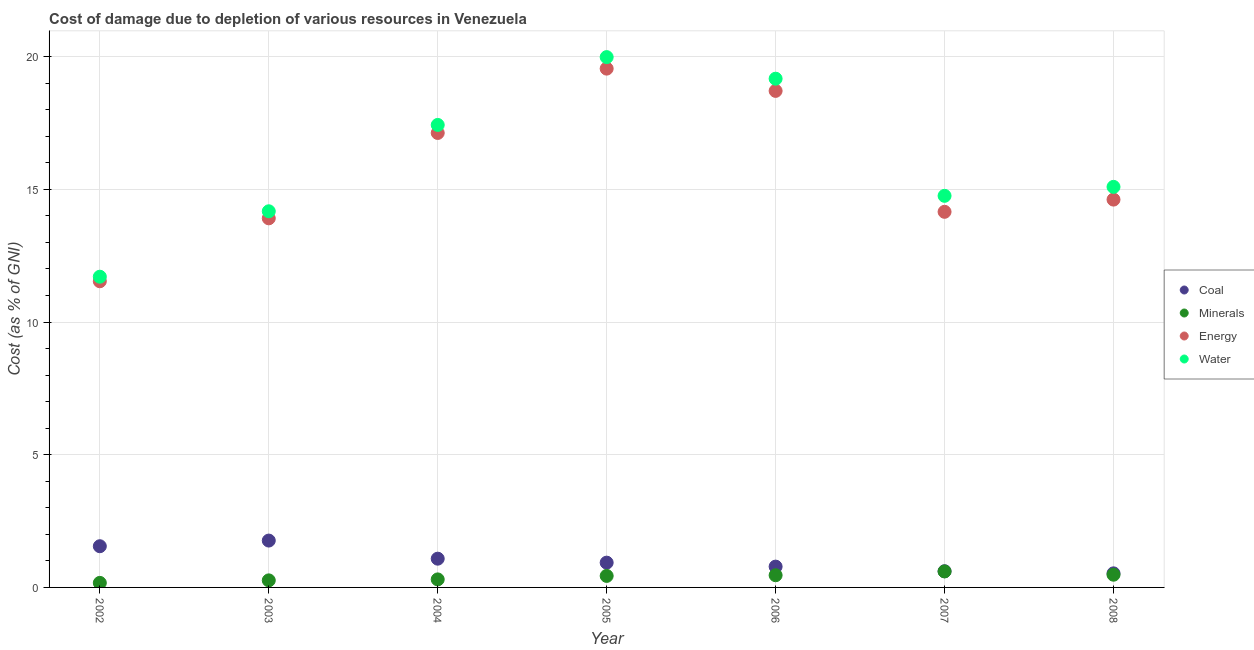Is the number of dotlines equal to the number of legend labels?
Offer a very short reply. Yes. What is the cost of damage due to depletion of energy in 2007?
Ensure brevity in your answer.  14.15. Across all years, what is the maximum cost of damage due to depletion of water?
Provide a succinct answer. 19.98. Across all years, what is the minimum cost of damage due to depletion of minerals?
Offer a very short reply. 0.17. In which year was the cost of damage due to depletion of water maximum?
Offer a terse response. 2005. What is the total cost of damage due to depletion of coal in the graph?
Provide a succinct answer. 7.26. What is the difference between the cost of damage due to depletion of minerals in 2006 and that in 2008?
Provide a succinct answer. -0.02. What is the difference between the cost of damage due to depletion of minerals in 2006 and the cost of damage due to depletion of coal in 2005?
Make the answer very short. -0.47. What is the average cost of damage due to depletion of water per year?
Provide a succinct answer. 16.05. In the year 2007, what is the difference between the cost of damage due to depletion of coal and cost of damage due to depletion of water?
Keep it short and to the point. -14.15. In how many years, is the cost of damage due to depletion of coal greater than 5 %?
Offer a terse response. 0. What is the ratio of the cost of damage due to depletion of energy in 2003 to that in 2005?
Make the answer very short. 0.71. What is the difference between the highest and the second highest cost of damage due to depletion of coal?
Your response must be concise. 0.21. What is the difference between the highest and the lowest cost of damage due to depletion of energy?
Offer a very short reply. 8.01. In how many years, is the cost of damage due to depletion of minerals greater than the average cost of damage due to depletion of minerals taken over all years?
Offer a very short reply. 4. Is it the case that in every year, the sum of the cost of damage due to depletion of coal and cost of damage due to depletion of minerals is greater than the cost of damage due to depletion of energy?
Make the answer very short. No. Is the cost of damage due to depletion of energy strictly greater than the cost of damage due to depletion of water over the years?
Provide a short and direct response. No. Is the cost of damage due to depletion of energy strictly less than the cost of damage due to depletion of water over the years?
Provide a succinct answer. Yes. How many dotlines are there?
Keep it short and to the point. 4. How many years are there in the graph?
Your response must be concise. 7. Where does the legend appear in the graph?
Offer a very short reply. Center right. How many legend labels are there?
Offer a very short reply. 4. How are the legend labels stacked?
Offer a very short reply. Vertical. What is the title of the graph?
Your response must be concise. Cost of damage due to depletion of various resources in Venezuela . What is the label or title of the X-axis?
Provide a short and direct response. Year. What is the label or title of the Y-axis?
Provide a succinct answer. Cost (as % of GNI). What is the Cost (as % of GNI) in Coal in 2002?
Provide a succinct answer. 1.55. What is the Cost (as % of GNI) in Minerals in 2002?
Provide a succinct answer. 0.17. What is the Cost (as % of GNI) in Energy in 2002?
Provide a succinct answer. 11.54. What is the Cost (as % of GNI) of Water in 2002?
Give a very brief answer. 11.71. What is the Cost (as % of GNI) in Coal in 2003?
Make the answer very short. 1.77. What is the Cost (as % of GNI) of Minerals in 2003?
Your answer should be very brief. 0.27. What is the Cost (as % of GNI) of Energy in 2003?
Ensure brevity in your answer.  13.91. What is the Cost (as % of GNI) of Water in 2003?
Offer a terse response. 14.17. What is the Cost (as % of GNI) in Coal in 2004?
Give a very brief answer. 1.08. What is the Cost (as % of GNI) in Minerals in 2004?
Provide a succinct answer. 0.3. What is the Cost (as % of GNI) in Energy in 2004?
Make the answer very short. 17.13. What is the Cost (as % of GNI) of Water in 2004?
Offer a very short reply. 17.43. What is the Cost (as % of GNI) in Coal in 2005?
Provide a succinct answer. 0.93. What is the Cost (as % of GNI) of Minerals in 2005?
Provide a short and direct response. 0.43. What is the Cost (as % of GNI) in Energy in 2005?
Ensure brevity in your answer.  19.55. What is the Cost (as % of GNI) of Water in 2005?
Offer a terse response. 19.98. What is the Cost (as % of GNI) in Coal in 2006?
Keep it short and to the point. 0.78. What is the Cost (as % of GNI) in Minerals in 2006?
Ensure brevity in your answer.  0.46. What is the Cost (as % of GNI) in Energy in 2006?
Offer a very short reply. 18.71. What is the Cost (as % of GNI) in Water in 2006?
Keep it short and to the point. 19.17. What is the Cost (as % of GNI) in Coal in 2007?
Give a very brief answer. 0.61. What is the Cost (as % of GNI) of Minerals in 2007?
Offer a very short reply. 0.6. What is the Cost (as % of GNI) in Energy in 2007?
Provide a short and direct response. 14.15. What is the Cost (as % of GNI) in Water in 2007?
Your answer should be very brief. 14.76. What is the Cost (as % of GNI) of Coal in 2008?
Provide a succinct answer. 0.53. What is the Cost (as % of GNI) of Minerals in 2008?
Offer a very short reply. 0.48. What is the Cost (as % of GNI) of Energy in 2008?
Provide a short and direct response. 14.62. What is the Cost (as % of GNI) in Water in 2008?
Make the answer very short. 15.09. Across all years, what is the maximum Cost (as % of GNI) of Coal?
Keep it short and to the point. 1.77. Across all years, what is the maximum Cost (as % of GNI) of Minerals?
Offer a very short reply. 0.6. Across all years, what is the maximum Cost (as % of GNI) of Energy?
Provide a short and direct response. 19.55. Across all years, what is the maximum Cost (as % of GNI) in Water?
Make the answer very short. 19.98. Across all years, what is the minimum Cost (as % of GNI) in Coal?
Your answer should be compact. 0.53. Across all years, what is the minimum Cost (as % of GNI) of Minerals?
Make the answer very short. 0.17. Across all years, what is the minimum Cost (as % of GNI) of Energy?
Give a very brief answer. 11.54. Across all years, what is the minimum Cost (as % of GNI) of Water?
Provide a succinct answer. 11.71. What is the total Cost (as % of GNI) of Coal in the graph?
Keep it short and to the point. 7.26. What is the total Cost (as % of GNI) in Minerals in the graph?
Offer a very short reply. 2.71. What is the total Cost (as % of GNI) in Energy in the graph?
Give a very brief answer. 109.61. What is the total Cost (as % of GNI) of Water in the graph?
Offer a very short reply. 112.32. What is the difference between the Cost (as % of GNI) in Coal in 2002 and that in 2003?
Offer a very short reply. -0.21. What is the difference between the Cost (as % of GNI) of Minerals in 2002 and that in 2003?
Make the answer very short. -0.1. What is the difference between the Cost (as % of GNI) in Energy in 2002 and that in 2003?
Your response must be concise. -2.37. What is the difference between the Cost (as % of GNI) of Water in 2002 and that in 2003?
Offer a very short reply. -2.47. What is the difference between the Cost (as % of GNI) of Coal in 2002 and that in 2004?
Your answer should be very brief. 0.47. What is the difference between the Cost (as % of GNI) of Minerals in 2002 and that in 2004?
Your answer should be very brief. -0.13. What is the difference between the Cost (as % of GNI) of Energy in 2002 and that in 2004?
Keep it short and to the point. -5.59. What is the difference between the Cost (as % of GNI) in Water in 2002 and that in 2004?
Ensure brevity in your answer.  -5.72. What is the difference between the Cost (as % of GNI) in Coal in 2002 and that in 2005?
Offer a terse response. 0.62. What is the difference between the Cost (as % of GNI) of Minerals in 2002 and that in 2005?
Make the answer very short. -0.26. What is the difference between the Cost (as % of GNI) in Energy in 2002 and that in 2005?
Keep it short and to the point. -8.01. What is the difference between the Cost (as % of GNI) in Water in 2002 and that in 2005?
Offer a very short reply. -8.28. What is the difference between the Cost (as % of GNI) of Coal in 2002 and that in 2006?
Your answer should be very brief. 0.77. What is the difference between the Cost (as % of GNI) of Minerals in 2002 and that in 2006?
Provide a succinct answer. -0.29. What is the difference between the Cost (as % of GNI) in Energy in 2002 and that in 2006?
Ensure brevity in your answer.  -7.17. What is the difference between the Cost (as % of GNI) of Water in 2002 and that in 2006?
Give a very brief answer. -7.46. What is the difference between the Cost (as % of GNI) of Coal in 2002 and that in 2007?
Ensure brevity in your answer.  0.94. What is the difference between the Cost (as % of GNI) of Minerals in 2002 and that in 2007?
Your answer should be compact. -0.43. What is the difference between the Cost (as % of GNI) in Energy in 2002 and that in 2007?
Your answer should be very brief. -2.62. What is the difference between the Cost (as % of GNI) of Water in 2002 and that in 2007?
Ensure brevity in your answer.  -3.05. What is the difference between the Cost (as % of GNI) of Coal in 2002 and that in 2008?
Your answer should be very brief. 1.02. What is the difference between the Cost (as % of GNI) in Minerals in 2002 and that in 2008?
Ensure brevity in your answer.  -0.31. What is the difference between the Cost (as % of GNI) of Energy in 2002 and that in 2008?
Offer a very short reply. -3.08. What is the difference between the Cost (as % of GNI) in Water in 2002 and that in 2008?
Provide a succinct answer. -3.39. What is the difference between the Cost (as % of GNI) in Coal in 2003 and that in 2004?
Your answer should be compact. 0.68. What is the difference between the Cost (as % of GNI) in Minerals in 2003 and that in 2004?
Your answer should be compact. -0.04. What is the difference between the Cost (as % of GNI) of Energy in 2003 and that in 2004?
Offer a terse response. -3.22. What is the difference between the Cost (as % of GNI) of Water in 2003 and that in 2004?
Ensure brevity in your answer.  -3.25. What is the difference between the Cost (as % of GNI) in Coal in 2003 and that in 2005?
Provide a short and direct response. 0.83. What is the difference between the Cost (as % of GNI) of Minerals in 2003 and that in 2005?
Your answer should be very brief. -0.17. What is the difference between the Cost (as % of GNI) in Energy in 2003 and that in 2005?
Keep it short and to the point. -5.64. What is the difference between the Cost (as % of GNI) in Water in 2003 and that in 2005?
Provide a succinct answer. -5.81. What is the difference between the Cost (as % of GNI) of Coal in 2003 and that in 2006?
Give a very brief answer. 0.98. What is the difference between the Cost (as % of GNI) of Minerals in 2003 and that in 2006?
Offer a terse response. -0.19. What is the difference between the Cost (as % of GNI) of Energy in 2003 and that in 2006?
Ensure brevity in your answer.  -4.8. What is the difference between the Cost (as % of GNI) of Water in 2003 and that in 2006?
Make the answer very short. -5. What is the difference between the Cost (as % of GNI) of Coal in 2003 and that in 2007?
Provide a short and direct response. 1.16. What is the difference between the Cost (as % of GNI) of Minerals in 2003 and that in 2007?
Provide a short and direct response. -0.34. What is the difference between the Cost (as % of GNI) in Energy in 2003 and that in 2007?
Give a very brief answer. -0.25. What is the difference between the Cost (as % of GNI) of Water in 2003 and that in 2007?
Make the answer very short. -0.58. What is the difference between the Cost (as % of GNI) of Coal in 2003 and that in 2008?
Your response must be concise. 1.24. What is the difference between the Cost (as % of GNI) in Minerals in 2003 and that in 2008?
Offer a very short reply. -0.21. What is the difference between the Cost (as % of GNI) of Energy in 2003 and that in 2008?
Your answer should be compact. -0.71. What is the difference between the Cost (as % of GNI) in Water in 2003 and that in 2008?
Provide a short and direct response. -0.92. What is the difference between the Cost (as % of GNI) in Coal in 2004 and that in 2005?
Keep it short and to the point. 0.15. What is the difference between the Cost (as % of GNI) of Minerals in 2004 and that in 2005?
Give a very brief answer. -0.13. What is the difference between the Cost (as % of GNI) in Energy in 2004 and that in 2005?
Provide a short and direct response. -2.42. What is the difference between the Cost (as % of GNI) of Water in 2004 and that in 2005?
Your answer should be very brief. -2.56. What is the difference between the Cost (as % of GNI) in Coal in 2004 and that in 2006?
Provide a succinct answer. 0.3. What is the difference between the Cost (as % of GNI) in Minerals in 2004 and that in 2006?
Provide a succinct answer. -0.16. What is the difference between the Cost (as % of GNI) of Energy in 2004 and that in 2006?
Give a very brief answer. -1.59. What is the difference between the Cost (as % of GNI) of Water in 2004 and that in 2006?
Your response must be concise. -1.74. What is the difference between the Cost (as % of GNI) in Coal in 2004 and that in 2007?
Ensure brevity in your answer.  0.47. What is the difference between the Cost (as % of GNI) in Minerals in 2004 and that in 2007?
Your response must be concise. -0.3. What is the difference between the Cost (as % of GNI) of Energy in 2004 and that in 2007?
Your response must be concise. 2.97. What is the difference between the Cost (as % of GNI) of Water in 2004 and that in 2007?
Make the answer very short. 2.67. What is the difference between the Cost (as % of GNI) of Coal in 2004 and that in 2008?
Your answer should be compact. 0.55. What is the difference between the Cost (as % of GNI) in Minerals in 2004 and that in 2008?
Offer a terse response. -0.18. What is the difference between the Cost (as % of GNI) of Energy in 2004 and that in 2008?
Offer a very short reply. 2.51. What is the difference between the Cost (as % of GNI) of Water in 2004 and that in 2008?
Keep it short and to the point. 2.33. What is the difference between the Cost (as % of GNI) in Coal in 2005 and that in 2006?
Offer a terse response. 0.15. What is the difference between the Cost (as % of GNI) of Minerals in 2005 and that in 2006?
Give a very brief answer. -0.03. What is the difference between the Cost (as % of GNI) in Energy in 2005 and that in 2006?
Provide a short and direct response. 0.84. What is the difference between the Cost (as % of GNI) of Water in 2005 and that in 2006?
Offer a terse response. 0.81. What is the difference between the Cost (as % of GNI) of Coal in 2005 and that in 2007?
Provide a succinct answer. 0.32. What is the difference between the Cost (as % of GNI) of Minerals in 2005 and that in 2007?
Your answer should be compact. -0.17. What is the difference between the Cost (as % of GNI) of Energy in 2005 and that in 2007?
Your answer should be compact. 5.4. What is the difference between the Cost (as % of GNI) of Water in 2005 and that in 2007?
Keep it short and to the point. 5.23. What is the difference between the Cost (as % of GNI) in Coal in 2005 and that in 2008?
Your answer should be compact. 0.4. What is the difference between the Cost (as % of GNI) of Minerals in 2005 and that in 2008?
Provide a succinct answer. -0.05. What is the difference between the Cost (as % of GNI) of Energy in 2005 and that in 2008?
Give a very brief answer. 4.94. What is the difference between the Cost (as % of GNI) in Water in 2005 and that in 2008?
Ensure brevity in your answer.  4.89. What is the difference between the Cost (as % of GNI) in Coal in 2006 and that in 2007?
Offer a very short reply. 0.17. What is the difference between the Cost (as % of GNI) of Minerals in 2006 and that in 2007?
Keep it short and to the point. -0.14. What is the difference between the Cost (as % of GNI) of Energy in 2006 and that in 2007?
Keep it short and to the point. 4.56. What is the difference between the Cost (as % of GNI) of Water in 2006 and that in 2007?
Ensure brevity in your answer.  4.41. What is the difference between the Cost (as % of GNI) of Coal in 2006 and that in 2008?
Provide a succinct answer. 0.25. What is the difference between the Cost (as % of GNI) in Minerals in 2006 and that in 2008?
Your answer should be very brief. -0.02. What is the difference between the Cost (as % of GNI) in Energy in 2006 and that in 2008?
Give a very brief answer. 4.1. What is the difference between the Cost (as % of GNI) in Water in 2006 and that in 2008?
Provide a succinct answer. 4.08. What is the difference between the Cost (as % of GNI) in Coal in 2007 and that in 2008?
Offer a terse response. 0.08. What is the difference between the Cost (as % of GNI) in Minerals in 2007 and that in 2008?
Give a very brief answer. 0.12. What is the difference between the Cost (as % of GNI) of Energy in 2007 and that in 2008?
Your response must be concise. -0.46. What is the difference between the Cost (as % of GNI) in Water in 2007 and that in 2008?
Offer a terse response. -0.34. What is the difference between the Cost (as % of GNI) of Coal in 2002 and the Cost (as % of GNI) of Minerals in 2003?
Provide a succinct answer. 1.29. What is the difference between the Cost (as % of GNI) of Coal in 2002 and the Cost (as % of GNI) of Energy in 2003?
Keep it short and to the point. -12.36. What is the difference between the Cost (as % of GNI) in Coal in 2002 and the Cost (as % of GNI) in Water in 2003?
Your response must be concise. -12.62. What is the difference between the Cost (as % of GNI) of Minerals in 2002 and the Cost (as % of GNI) of Energy in 2003?
Offer a terse response. -13.74. What is the difference between the Cost (as % of GNI) of Minerals in 2002 and the Cost (as % of GNI) of Water in 2003?
Provide a short and direct response. -14. What is the difference between the Cost (as % of GNI) of Energy in 2002 and the Cost (as % of GNI) of Water in 2003?
Keep it short and to the point. -2.64. What is the difference between the Cost (as % of GNI) in Coal in 2002 and the Cost (as % of GNI) in Minerals in 2004?
Offer a very short reply. 1.25. What is the difference between the Cost (as % of GNI) in Coal in 2002 and the Cost (as % of GNI) in Energy in 2004?
Keep it short and to the point. -15.57. What is the difference between the Cost (as % of GNI) of Coal in 2002 and the Cost (as % of GNI) of Water in 2004?
Offer a very short reply. -15.88. What is the difference between the Cost (as % of GNI) of Minerals in 2002 and the Cost (as % of GNI) of Energy in 2004?
Offer a terse response. -16.96. What is the difference between the Cost (as % of GNI) in Minerals in 2002 and the Cost (as % of GNI) in Water in 2004?
Ensure brevity in your answer.  -17.26. What is the difference between the Cost (as % of GNI) in Energy in 2002 and the Cost (as % of GNI) in Water in 2004?
Provide a short and direct response. -5.89. What is the difference between the Cost (as % of GNI) of Coal in 2002 and the Cost (as % of GNI) of Minerals in 2005?
Ensure brevity in your answer.  1.12. What is the difference between the Cost (as % of GNI) in Coal in 2002 and the Cost (as % of GNI) in Energy in 2005?
Your answer should be very brief. -18. What is the difference between the Cost (as % of GNI) of Coal in 2002 and the Cost (as % of GNI) of Water in 2005?
Give a very brief answer. -18.43. What is the difference between the Cost (as % of GNI) in Minerals in 2002 and the Cost (as % of GNI) in Energy in 2005?
Keep it short and to the point. -19.38. What is the difference between the Cost (as % of GNI) of Minerals in 2002 and the Cost (as % of GNI) of Water in 2005?
Make the answer very short. -19.81. What is the difference between the Cost (as % of GNI) of Energy in 2002 and the Cost (as % of GNI) of Water in 2005?
Keep it short and to the point. -8.45. What is the difference between the Cost (as % of GNI) of Coal in 2002 and the Cost (as % of GNI) of Minerals in 2006?
Make the answer very short. 1.09. What is the difference between the Cost (as % of GNI) in Coal in 2002 and the Cost (as % of GNI) in Energy in 2006?
Provide a succinct answer. -17.16. What is the difference between the Cost (as % of GNI) in Coal in 2002 and the Cost (as % of GNI) in Water in 2006?
Your response must be concise. -17.62. What is the difference between the Cost (as % of GNI) in Minerals in 2002 and the Cost (as % of GNI) in Energy in 2006?
Provide a succinct answer. -18.54. What is the difference between the Cost (as % of GNI) in Minerals in 2002 and the Cost (as % of GNI) in Water in 2006?
Ensure brevity in your answer.  -19. What is the difference between the Cost (as % of GNI) in Energy in 2002 and the Cost (as % of GNI) in Water in 2006?
Give a very brief answer. -7.63. What is the difference between the Cost (as % of GNI) in Coal in 2002 and the Cost (as % of GNI) in Minerals in 2007?
Your answer should be compact. 0.95. What is the difference between the Cost (as % of GNI) in Coal in 2002 and the Cost (as % of GNI) in Energy in 2007?
Your answer should be compact. -12.6. What is the difference between the Cost (as % of GNI) of Coal in 2002 and the Cost (as % of GNI) of Water in 2007?
Keep it short and to the point. -13.2. What is the difference between the Cost (as % of GNI) of Minerals in 2002 and the Cost (as % of GNI) of Energy in 2007?
Ensure brevity in your answer.  -13.98. What is the difference between the Cost (as % of GNI) in Minerals in 2002 and the Cost (as % of GNI) in Water in 2007?
Provide a short and direct response. -14.59. What is the difference between the Cost (as % of GNI) of Energy in 2002 and the Cost (as % of GNI) of Water in 2007?
Provide a short and direct response. -3.22. What is the difference between the Cost (as % of GNI) in Coal in 2002 and the Cost (as % of GNI) in Minerals in 2008?
Provide a succinct answer. 1.07. What is the difference between the Cost (as % of GNI) of Coal in 2002 and the Cost (as % of GNI) of Energy in 2008?
Your response must be concise. -13.06. What is the difference between the Cost (as % of GNI) in Coal in 2002 and the Cost (as % of GNI) in Water in 2008?
Offer a very short reply. -13.54. What is the difference between the Cost (as % of GNI) in Minerals in 2002 and the Cost (as % of GNI) in Energy in 2008?
Make the answer very short. -14.44. What is the difference between the Cost (as % of GNI) of Minerals in 2002 and the Cost (as % of GNI) of Water in 2008?
Your response must be concise. -14.92. What is the difference between the Cost (as % of GNI) in Energy in 2002 and the Cost (as % of GNI) in Water in 2008?
Your response must be concise. -3.56. What is the difference between the Cost (as % of GNI) in Coal in 2003 and the Cost (as % of GNI) in Minerals in 2004?
Your response must be concise. 1.46. What is the difference between the Cost (as % of GNI) of Coal in 2003 and the Cost (as % of GNI) of Energy in 2004?
Provide a short and direct response. -15.36. What is the difference between the Cost (as % of GNI) in Coal in 2003 and the Cost (as % of GNI) in Water in 2004?
Your answer should be very brief. -15.66. What is the difference between the Cost (as % of GNI) in Minerals in 2003 and the Cost (as % of GNI) in Energy in 2004?
Give a very brief answer. -16.86. What is the difference between the Cost (as % of GNI) in Minerals in 2003 and the Cost (as % of GNI) in Water in 2004?
Offer a very short reply. -17.16. What is the difference between the Cost (as % of GNI) in Energy in 2003 and the Cost (as % of GNI) in Water in 2004?
Ensure brevity in your answer.  -3.52. What is the difference between the Cost (as % of GNI) in Coal in 2003 and the Cost (as % of GNI) in Minerals in 2005?
Your answer should be very brief. 1.33. What is the difference between the Cost (as % of GNI) in Coal in 2003 and the Cost (as % of GNI) in Energy in 2005?
Offer a very short reply. -17.79. What is the difference between the Cost (as % of GNI) of Coal in 2003 and the Cost (as % of GNI) of Water in 2005?
Your response must be concise. -18.22. What is the difference between the Cost (as % of GNI) in Minerals in 2003 and the Cost (as % of GNI) in Energy in 2005?
Your response must be concise. -19.28. What is the difference between the Cost (as % of GNI) in Minerals in 2003 and the Cost (as % of GNI) in Water in 2005?
Your response must be concise. -19.72. What is the difference between the Cost (as % of GNI) of Energy in 2003 and the Cost (as % of GNI) of Water in 2005?
Give a very brief answer. -6.08. What is the difference between the Cost (as % of GNI) of Coal in 2003 and the Cost (as % of GNI) of Minerals in 2006?
Make the answer very short. 1.31. What is the difference between the Cost (as % of GNI) in Coal in 2003 and the Cost (as % of GNI) in Energy in 2006?
Provide a short and direct response. -16.95. What is the difference between the Cost (as % of GNI) of Coal in 2003 and the Cost (as % of GNI) of Water in 2006?
Offer a terse response. -17.41. What is the difference between the Cost (as % of GNI) in Minerals in 2003 and the Cost (as % of GNI) in Energy in 2006?
Your answer should be compact. -18.45. What is the difference between the Cost (as % of GNI) of Minerals in 2003 and the Cost (as % of GNI) of Water in 2006?
Your answer should be compact. -18.91. What is the difference between the Cost (as % of GNI) of Energy in 2003 and the Cost (as % of GNI) of Water in 2006?
Make the answer very short. -5.26. What is the difference between the Cost (as % of GNI) of Coal in 2003 and the Cost (as % of GNI) of Minerals in 2007?
Your response must be concise. 1.16. What is the difference between the Cost (as % of GNI) in Coal in 2003 and the Cost (as % of GNI) in Energy in 2007?
Keep it short and to the point. -12.39. What is the difference between the Cost (as % of GNI) in Coal in 2003 and the Cost (as % of GNI) in Water in 2007?
Keep it short and to the point. -12.99. What is the difference between the Cost (as % of GNI) of Minerals in 2003 and the Cost (as % of GNI) of Energy in 2007?
Ensure brevity in your answer.  -13.89. What is the difference between the Cost (as % of GNI) of Minerals in 2003 and the Cost (as % of GNI) of Water in 2007?
Offer a terse response. -14.49. What is the difference between the Cost (as % of GNI) of Energy in 2003 and the Cost (as % of GNI) of Water in 2007?
Ensure brevity in your answer.  -0.85. What is the difference between the Cost (as % of GNI) in Coal in 2003 and the Cost (as % of GNI) in Minerals in 2008?
Your answer should be very brief. 1.29. What is the difference between the Cost (as % of GNI) in Coal in 2003 and the Cost (as % of GNI) in Energy in 2008?
Make the answer very short. -12.85. What is the difference between the Cost (as % of GNI) in Coal in 2003 and the Cost (as % of GNI) in Water in 2008?
Provide a succinct answer. -13.33. What is the difference between the Cost (as % of GNI) of Minerals in 2003 and the Cost (as % of GNI) of Energy in 2008?
Your answer should be very brief. -14.35. What is the difference between the Cost (as % of GNI) of Minerals in 2003 and the Cost (as % of GNI) of Water in 2008?
Provide a short and direct response. -14.83. What is the difference between the Cost (as % of GNI) of Energy in 2003 and the Cost (as % of GNI) of Water in 2008?
Your answer should be compact. -1.19. What is the difference between the Cost (as % of GNI) in Coal in 2004 and the Cost (as % of GNI) in Minerals in 2005?
Offer a very short reply. 0.65. What is the difference between the Cost (as % of GNI) of Coal in 2004 and the Cost (as % of GNI) of Energy in 2005?
Offer a terse response. -18.47. What is the difference between the Cost (as % of GNI) in Coal in 2004 and the Cost (as % of GNI) in Water in 2005?
Offer a terse response. -18.9. What is the difference between the Cost (as % of GNI) in Minerals in 2004 and the Cost (as % of GNI) in Energy in 2005?
Offer a terse response. -19.25. What is the difference between the Cost (as % of GNI) in Minerals in 2004 and the Cost (as % of GNI) in Water in 2005?
Provide a succinct answer. -19.68. What is the difference between the Cost (as % of GNI) in Energy in 2004 and the Cost (as % of GNI) in Water in 2005?
Your answer should be compact. -2.86. What is the difference between the Cost (as % of GNI) in Coal in 2004 and the Cost (as % of GNI) in Minerals in 2006?
Keep it short and to the point. 0.62. What is the difference between the Cost (as % of GNI) in Coal in 2004 and the Cost (as % of GNI) in Energy in 2006?
Your answer should be compact. -17.63. What is the difference between the Cost (as % of GNI) of Coal in 2004 and the Cost (as % of GNI) of Water in 2006?
Your answer should be compact. -18.09. What is the difference between the Cost (as % of GNI) in Minerals in 2004 and the Cost (as % of GNI) in Energy in 2006?
Your answer should be compact. -18.41. What is the difference between the Cost (as % of GNI) of Minerals in 2004 and the Cost (as % of GNI) of Water in 2006?
Provide a succinct answer. -18.87. What is the difference between the Cost (as % of GNI) in Energy in 2004 and the Cost (as % of GNI) in Water in 2006?
Provide a succinct answer. -2.04. What is the difference between the Cost (as % of GNI) of Coal in 2004 and the Cost (as % of GNI) of Minerals in 2007?
Make the answer very short. 0.48. What is the difference between the Cost (as % of GNI) of Coal in 2004 and the Cost (as % of GNI) of Energy in 2007?
Make the answer very short. -13.07. What is the difference between the Cost (as % of GNI) of Coal in 2004 and the Cost (as % of GNI) of Water in 2007?
Your answer should be very brief. -13.67. What is the difference between the Cost (as % of GNI) in Minerals in 2004 and the Cost (as % of GNI) in Energy in 2007?
Keep it short and to the point. -13.85. What is the difference between the Cost (as % of GNI) in Minerals in 2004 and the Cost (as % of GNI) in Water in 2007?
Offer a terse response. -14.45. What is the difference between the Cost (as % of GNI) in Energy in 2004 and the Cost (as % of GNI) in Water in 2007?
Your answer should be compact. 2.37. What is the difference between the Cost (as % of GNI) in Coal in 2004 and the Cost (as % of GNI) in Minerals in 2008?
Give a very brief answer. 0.6. What is the difference between the Cost (as % of GNI) of Coal in 2004 and the Cost (as % of GNI) of Energy in 2008?
Give a very brief answer. -13.53. What is the difference between the Cost (as % of GNI) in Coal in 2004 and the Cost (as % of GNI) in Water in 2008?
Your answer should be very brief. -14.01. What is the difference between the Cost (as % of GNI) in Minerals in 2004 and the Cost (as % of GNI) in Energy in 2008?
Offer a very short reply. -14.31. What is the difference between the Cost (as % of GNI) of Minerals in 2004 and the Cost (as % of GNI) of Water in 2008?
Give a very brief answer. -14.79. What is the difference between the Cost (as % of GNI) in Energy in 2004 and the Cost (as % of GNI) in Water in 2008?
Make the answer very short. 2.03. What is the difference between the Cost (as % of GNI) in Coal in 2005 and the Cost (as % of GNI) in Minerals in 2006?
Provide a short and direct response. 0.47. What is the difference between the Cost (as % of GNI) in Coal in 2005 and the Cost (as % of GNI) in Energy in 2006?
Your answer should be very brief. -17.78. What is the difference between the Cost (as % of GNI) in Coal in 2005 and the Cost (as % of GNI) in Water in 2006?
Your response must be concise. -18.24. What is the difference between the Cost (as % of GNI) of Minerals in 2005 and the Cost (as % of GNI) of Energy in 2006?
Your response must be concise. -18.28. What is the difference between the Cost (as % of GNI) in Minerals in 2005 and the Cost (as % of GNI) in Water in 2006?
Ensure brevity in your answer.  -18.74. What is the difference between the Cost (as % of GNI) in Energy in 2005 and the Cost (as % of GNI) in Water in 2006?
Your answer should be very brief. 0.38. What is the difference between the Cost (as % of GNI) in Coal in 2005 and the Cost (as % of GNI) in Minerals in 2007?
Provide a short and direct response. 0.33. What is the difference between the Cost (as % of GNI) in Coal in 2005 and the Cost (as % of GNI) in Energy in 2007?
Provide a succinct answer. -13.22. What is the difference between the Cost (as % of GNI) in Coal in 2005 and the Cost (as % of GNI) in Water in 2007?
Offer a very short reply. -13.82. What is the difference between the Cost (as % of GNI) in Minerals in 2005 and the Cost (as % of GNI) in Energy in 2007?
Give a very brief answer. -13.72. What is the difference between the Cost (as % of GNI) of Minerals in 2005 and the Cost (as % of GNI) of Water in 2007?
Offer a terse response. -14.32. What is the difference between the Cost (as % of GNI) in Energy in 2005 and the Cost (as % of GNI) in Water in 2007?
Keep it short and to the point. 4.79. What is the difference between the Cost (as % of GNI) of Coal in 2005 and the Cost (as % of GNI) of Minerals in 2008?
Your answer should be compact. 0.45. What is the difference between the Cost (as % of GNI) of Coal in 2005 and the Cost (as % of GNI) of Energy in 2008?
Provide a short and direct response. -13.68. What is the difference between the Cost (as % of GNI) in Coal in 2005 and the Cost (as % of GNI) in Water in 2008?
Give a very brief answer. -14.16. What is the difference between the Cost (as % of GNI) in Minerals in 2005 and the Cost (as % of GNI) in Energy in 2008?
Offer a terse response. -14.18. What is the difference between the Cost (as % of GNI) in Minerals in 2005 and the Cost (as % of GNI) in Water in 2008?
Provide a short and direct response. -14.66. What is the difference between the Cost (as % of GNI) of Energy in 2005 and the Cost (as % of GNI) of Water in 2008?
Ensure brevity in your answer.  4.46. What is the difference between the Cost (as % of GNI) of Coal in 2006 and the Cost (as % of GNI) of Minerals in 2007?
Give a very brief answer. 0.18. What is the difference between the Cost (as % of GNI) of Coal in 2006 and the Cost (as % of GNI) of Energy in 2007?
Your answer should be compact. -13.37. What is the difference between the Cost (as % of GNI) in Coal in 2006 and the Cost (as % of GNI) in Water in 2007?
Give a very brief answer. -13.97. What is the difference between the Cost (as % of GNI) in Minerals in 2006 and the Cost (as % of GNI) in Energy in 2007?
Offer a terse response. -13.7. What is the difference between the Cost (as % of GNI) of Minerals in 2006 and the Cost (as % of GNI) of Water in 2007?
Offer a terse response. -14.3. What is the difference between the Cost (as % of GNI) in Energy in 2006 and the Cost (as % of GNI) in Water in 2007?
Offer a terse response. 3.95. What is the difference between the Cost (as % of GNI) in Coal in 2006 and the Cost (as % of GNI) in Minerals in 2008?
Your answer should be very brief. 0.31. What is the difference between the Cost (as % of GNI) in Coal in 2006 and the Cost (as % of GNI) in Energy in 2008?
Your answer should be very brief. -13.83. What is the difference between the Cost (as % of GNI) of Coal in 2006 and the Cost (as % of GNI) of Water in 2008?
Provide a succinct answer. -14.31. What is the difference between the Cost (as % of GNI) of Minerals in 2006 and the Cost (as % of GNI) of Energy in 2008?
Provide a succinct answer. -14.16. What is the difference between the Cost (as % of GNI) in Minerals in 2006 and the Cost (as % of GNI) in Water in 2008?
Offer a very short reply. -14.63. What is the difference between the Cost (as % of GNI) in Energy in 2006 and the Cost (as % of GNI) in Water in 2008?
Your answer should be very brief. 3.62. What is the difference between the Cost (as % of GNI) in Coal in 2007 and the Cost (as % of GNI) in Minerals in 2008?
Give a very brief answer. 0.13. What is the difference between the Cost (as % of GNI) of Coal in 2007 and the Cost (as % of GNI) of Energy in 2008?
Keep it short and to the point. -14.01. What is the difference between the Cost (as % of GNI) of Coal in 2007 and the Cost (as % of GNI) of Water in 2008?
Your response must be concise. -14.48. What is the difference between the Cost (as % of GNI) of Minerals in 2007 and the Cost (as % of GNI) of Energy in 2008?
Your answer should be very brief. -14.01. What is the difference between the Cost (as % of GNI) of Minerals in 2007 and the Cost (as % of GNI) of Water in 2008?
Ensure brevity in your answer.  -14.49. What is the difference between the Cost (as % of GNI) in Energy in 2007 and the Cost (as % of GNI) in Water in 2008?
Ensure brevity in your answer.  -0.94. What is the average Cost (as % of GNI) of Coal per year?
Make the answer very short. 1.04. What is the average Cost (as % of GNI) in Minerals per year?
Ensure brevity in your answer.  0.39. What is the average Cost (as % of GNI) of Energy per year?
Make the answer very short. 15.66. What is the average Cost (as % of GNI) in Water per year?
Ensure brevity in your answer.  16.05. In the year 2002, what is the difference between the Cost (as % of GNI) of Coal and Cost (as % of GNI) of Minerals?
Your answer should be compact. 1.38. In the year 2002, what is the difference between the Cost (as % of GNI) in Coal and Cost (as % of GNI) in Energy?
Keep it short and to the point. -9.99. In the year 2002, what is the difference between the Cost (as % of GNI) of Coal and Cost (as % of GNI) of Water?
Provide a short and direct response. -10.16. In the year 2002, what is the difference between the Cost (as % of GNI) of Minerals and Cost (as % of GNI) of Energy?
Offer a terse response. -11.37. In the year 2002, what is the difference between the Cost (as % of GNI) of Minerals and Cost (as % of GNI) of Water?
Your response must be concise. -11.54. In the year 2002, what is the difference between the Cost (as % of GNI) in Energy and Cost (as % of GNI) in Water?
Your answer should be very brief. -0.17. In the year 2003, what is the difference between the Cost (as % of GNI) in Coal and Cost (as % of GNI) in Minerals?
Make the answer very short. 1.5. In the year 2003, what is the difference between the Cost (as % of GNI) in Coal and Cost (as % of GNI) in Energy?
Your response must be concise. -12.14. In the year 2003, what is the difference between the Cost (as % of GNI) of Coal and Cost (as % of GNI) of Water?
Make the answer very short. -12.41. In the year 2003, what is the difference between the Cost (as % of GNI) of Minerals and Cost (as % of GNI) of Energy?
Your answer should be compact. -13.64. In the year 2003, what is the difference between the Cost (as % of GNI) in Minerals and Cost (as % of GNI) in Water?
Keep it short and to the point. -13.91. In the year 2003, what is the difference between the Cost (as % of GNI) in Energy and Cost (as % of GNI) in Water?
Make the answer very short. -0.27. In the year 2004, what is the difference between the Cost (as % of GNI) in Coal and Cost (as % of GNI) in Minerals?
Give a very brief answer. 0.78. In the year 2004, what is the difference between the Cost (as % of GNI) in Coal and Cost (as % of GNI) in Energy?
Ensure brevity in your answer.  -16.04. In the year 2004, what is the difference between the Cost (as % of GNI) in Coal and Cost (as % of GNI) in Water?
Make the answer very short. -16.35. In the year 2004, what is the difference between the Cost (as % of GNI) in Minerals and Cost (as % of GNI) in Energy?
Your response must be concise. -16.82. In the year 2004, what is the difference between the Cost (as % of GNI) in Minerals and Cost (as % of GNI) in Water?
Provide a short and direct response. -17.13. In the year 2004, what is the difference between the Cost (as % of GNI) of Energy and Cost (as % of GNI) of Water?
Keep it short and to the point. -0.3. In the year 2005, what is the difference between the Cost (as % of GNI) in Coal and Cost (as % of GNI) in Minerals?
Your response must be concise. 0.5. In the year 2005, what is the difference between the Cost (as % of GNI) in Coal and Cost (as % of GNI) in Energy?
Your response must be concise. -18.62. In the year 2005, what is the difference between the Cost (as % of GNI) in Coal and Cost (as % of GNI) in Water?
Provide a short and direct response. -19.05. In the year 2005, what is the difference between the Cost (as % of GNI) of Minerals and Cost (as % of GNI) of Energy?
Provide a short and direct response. -19.12. In the year 2005, what is the difference between the Cost (as % of GNI) in Minerals and Cost (as % of GNI) in Water?
Your answer should be very brief. -19.55. In the year 2005, what is the difference between the Cost (as % of GNI) of Energy and Cost (as % of GNI) of Water?
Provide a succinct answer. -0.43. In the year 2006, what is the difference between the Cost (as % of GNI) of Coal and Cost (as % of GNI) of Minerals?
Your response must be concise. 0.32. In the year 2006, what is the difference between the Cost (as % of GNI) in Coal and Cost (as % of GNI) in Energy?
Offer a very short reply. -17.93. In the year 2006, what is the difference between the Cost (as % of GNI) in Coal and Cost (as % of GNI) in Water?
Your answer should be very brief. -18.39. In the year 2006, what is the difference between the Cost (as % of GNI) in Minerals and Cost (as % of GNI) in Energy?
Make the answer very short. -18.25. In the year 2006, what is the difference between the Cost (as % of GNI) of Minerals and Cost (as % of GNI) of Water?
Your response must be concise. -18.71. In the year 2006, what is the difference between the Cost (as % of GNI) of Energy and Cost (as % of GNI) of Water?
Give a very brief answer. -0.46. In the year 2007, what is the difference between the Cost (as % of GNI) in Coal and Cost (as % of GNI) in Minerals?
Keep it short and to the point. 0.01. In the year 2007, what is the difference between the Cost (as % of GNI) of Coal and Cost (as % of GNI) of Energy?
Provide a succinct answer. -13.54. In the year 2007, what is the difference between the Cost (as % of GNI) of Coal and Cost (as % of GNI) of Water?
Give a very brief answer. -14.15. In the year 2007, what is the difference between the Cost (as % of GNI) of Minerals and Cost (as % of GNI) of Energy?
Your answer should be very brief. -13.55. In the year 2007, what is the difference between the Cost (as % of GNI) in Minerals and Cost (as % of GNI) in Water?
Ensure brevity in your answer.  -14.15. In the year 2007, what is the difference between the Cost (as % of GNI) in Energy and Cost (as % of GNI) in Water?
Provide a succinct answer. -0.6. In the year 2008, what is the difference between the Cost (as % of GNI) of Coal and Cost (as % of GNI) of Minerals?
Provide a succinct answer. 0.05. In the year 2008, what is the difference between the Cost (as % of GNI) in Coal and Cost (as % of GNI) in Energy?
Make the answer very short. -14.09. In the year 2008, what is the difference between the Cost (as % of GNI) in Coal and Cost (as % of GNI) in Water?
Keep it short and to the point. -14.56. In the year 2008, what is the difference between the Cost (as % of GNI) in Minerals and Cost (as % of GNI) in Energy?
Keep it short and to the point. -14.14. In the year 2008, what is the difference between the Cost (as % of GNI) of Minerals and Cost (as % of GNI) of Water?
Provide a short and direct response. -14.62. In the year 2008, what is the difference between the Cost (as % of GNI) in Energy and Cost (as % of GNI) in Water?
Offer a very short reply. -0.48. What is the ratio of the Cost (as % of GNI) of Coal in 2002 to that in 2003?
Keep it short and to the point. 0.88. What is the ratio of the Cost (as % of GNI) in Minerals in 2002 to that in 2003?
Offer a terse response. 0.64. What is the ratio of the Cost (as % of GNI) of Energy in 2002 to that in 2003?
Keep it short and to the point. 0.83. What is the ratio of the Cost (as % of GNI) of Water in 2002 to that in 2003?
Offer a terse response. 0.83. What is the ratio of the Cost (as % of GNI) in Coal in 2002 to that in 2004?
Make the answer very short. 1.43. What is the ratio of the Cost (as % of GNI) in Minerals in 2002 to that in 2004?
Give a very brief answer. 0.56. What is the ratio of the Cost (as % of GNI) in Energy in 2002 to that in 2004?
Make the answer very short. 0.67. What is the ratio of the Cost (as % of GNI) in Water in 2002 to that in 2004?
Your answer should be very brief. 0.67. What is the ratio of the Cost (as % of GNI) in Coal in 2002 to that in 2005?
Your response must be concise. 1.66. What is the ratio of the Cost (as % of GNI) of Minerals in 2002 to that in 2005?
Offer a terse response. 0.39. What is the ratio of the Cost (as % of GNI) of Energy in 2002 to that in 2005?
Your answer should be compact. 0.59. What is the ratio of the Cost (as % of GNI) in Water in 2002 to that in 2005?
Offer a terse response. 0.59. What is the ratio of the Cost (as % of GNI) in Coal in 2002 to that in 2006?
Provide a succinct answer. 1.98. What is the ratio of the Cost (as % of GNI) in Minerals in 2002 to that in 2006?
Your response must be concise. 0.37. What is the ratio of the Cost (as % of GNI) in Energy in 2002 to that in 2006?
Ensure brevity in your answer.  0.62. What is the ratio of the Cost (as % of GNI) of Water in 2002 to that in 2006?
Make the answer very short. 0.61. What is the ratio of the Cost (as % of GNI) in Coal in 2002 to that in 2007?
Your answer should be very brief. 2.54. What is the ratio of the Cost (as % of GNI) of Minerals in 2002 to that in 2007?
Give a very brief answer. 0.28. What is the ratio of the Cost (as % of GNI) in Energy in 2002 to that in 2007?
Keep it short and to the point. 0.82. What is the ratio of the Cost (as % of GNI) in Water in 2002 to that in 2007?
Your response must be concise. 0.79. What is the ratio of the Cost (as % of GNI) of Coal in 2002 to that in 2008?
Offer a very short reply. 2.93. What is the ratio of the Cost (as % of GNI) in Minerals in 2002 to that in 2008?
Your response must be concise. 0.36. What is the ratio of the Cost (as % of GNI) of Energy in 2002 to that in 2008?
Your response must be concise. 0.79. What is the ratio of the Cost (as % of GNI) of Water in 2002 to that in 2008?
Your response must be concise. 0.78. What is the ratio of the Cost (as % of GNI) of Coal in 2003 to that in 2004?
Provide a short and direct response. 1.63. What is the ratio of the Cost (as % of GNI) of Minerals in 2003 to that in 2004?
Give a very brief answer. 0.88. What is the ratio of the Cost (as % of GNI) of Energy in 2003 to that in 2004?
Give a very brief answer. 0.81. What is the ratio of the Cost (as % of GNI) of Water in 2003 to that in 2004?
Your answer should be compact. 0.81. What is the ratio of the Cost (as % of GNI) of Coal in 2003 to that in 2005?
Your response must be concise. 1.89. What is the ratio of the Cost (as % of GNI) in Minerals in 2003 to that in 2005?
Provide a succinct answer. 0.61. What is the ratio of the Cost (as % of GNI) in Energy in 2003 to that in 2005?
Provide a short and direct response. 0.71. What is the ratio of the Cost (as % of GNI) in Water in 2003 to that in 2005?
Provide a succinct answer. 0.71. What is the ratio of the Cost (as % of GNI) in Coal in 2003 to that in 2006?
Offer a very short reply. 2.25. What is the ratio of the Cost (as % of GNI) of Minerals in 2003 to that in 2006?
Keep it short and to the point. 0.58. What is the ratio of the Cost (as % of GNI) in Energy in 2003 to that in 2006?
Make the answer very short. 0.74. What is the ratio of the Cost (as % of GNI) of Water in 2003 to that in 2006?
Ensure brevity in your answer.  0.74. What is the ratio of the Cost (as % of GNI) in Coal in 2003 to that in 2007?
Your response must be concise. 2.89. What is the ratio of the Cost (as % of GNI) of Minerals in 2003 to that in 2007?
Your answer should be very brief. 0.44. What is the ratio of the Cost (as % of GNI) in Energy in 2003 to that in 2007?
Provide a succinct answer. 0.98. What is the ratio of the Cost (as % of GNI) in Water in 2003 to that in 2007?
Keep it short and to the point. 0.96. What is the ratio of the Cost (as % of GNI) of Coal in 2003 to that in 2008?
Offer a terse response. 3.33. What is the ratio of the Cost (as % of GNI) of Minerals in 2003 to that in 2008?
Offer a very short reply. 0.56. What is the ratio of the Cost (as % of GNI) of Energy in 2003 to that in 2008?
Your answer should be compact. 0.95. What is the ratio of the Cost (as % of GNI) of Water in 2003 to that in 2008?
Ensure brevity in your answer.  0.94. What is the ratio of the Cost (as % of GNI) of Coal in 2004 to that in 2005?
Provide a short and direct response. 1.16. What is the ratio of the Cost (as % of GNI) in Minerals in 2004 to that in 2005?
Your response must be concise. 0.7. What is the ratio of the Cost (as % of GNI) in Energy in 2004 to that in 2005?
Keep it short and to the point. 0.88. What is the ratio of the Cost (as % of GNI) in Water in 2004 to that in 2005?
Make the answer very short. 0.87. What is the ratio of the Cost (as % of GNI) in Coal in 2004 to that in 2006?
Offer a terse response. 1.38. What is the ratio of the Cost (as % of GNI) of Minerals in 2004 to that in 2006?
Make the answer very short. 0.66. What is the ratio of the Cost (as % of GNI) in Energy in 2004 to that in 2006?
Give a very brief answer. 0.92. What is the ratio of the Cost (as % of GNI) in Water in 2004 to that in 2006?
Provide a succinct answer. 0.91. What is the ratio of the Cost (as % of GNI) of Coal in 2004 to that in 2007?
Give a very brief answer. 1.78. What is the ratio of the Cost (as % of GNI) of Minerals in 2004 to that in 2007?
Your answer should be very brief. 0.5. What is the ratio of the Cost (as % of GNI) in Energy in 2004 to that in 2007?
Your answer should be compact. 1.21. What is the ratio of the Cost (as % of GNI) of Water in 2004 to that in 2007?
Your answer should be compact. 1.18. What is the ratio of the Cost (as % of GNI) of Coal in 2004 to that in 2008?
Make the answer very short. 2.04. What is the ratio of the Cost (as % of GNI) of Minerals in 2004 to that in 2008?
Your answer should be compact. 0.63. What is the ratio of the Cost (as % of GNI) in Energy in 2004 to that in 2008?
Offer a terse response. 1.17. What is the ratio of the Cost (as % of GNI) in Water in 2004 to that in 2008?
Ensure brevity in your answer.  1.15. What is the ratio of the Cost (as % of GNI) in Coal in 2005 to that in 2006?
Your response must be concise. 1.19. What is the ratio of the Cost (as % of GNI) of Energy in 2005 to that in 2006?
Your answer should be compact. 1.04. What is the ratio of the Cost (as % of GNI) of Water in 2005 to that in 2006?
Keep it short and to the point. 1.04. What is the ratio of the Cost (as % of GNI) in Coal in 2005 to that in 2007?
Offer a very short reply. 1.53. What is the ratio of the Cost (as % of GNI) in Minerals in 2005 to that in 2007?
Your answer should be very brief. 0.72. What is the ratio of the Cost (as % of GNI) of Energy in 2005 to that in 2007?
Ensure brevity in your answer.  1.38. What is the ratio of the Cost (as % of GNI) of Water in 2005 to that in 2007?
Provide a short and direct response. 1.35. What is the ratio of the Cost (as % of GNI) in Coal in 2005 to that in 2008?
Provide a succinct answer. 1.76. What is the ratio of the Cost (as % of GNI) of Minerals in 2005 to that in 2008?
Provide a succinct answer. 0.91. What is the ratio of the Cost (as % of GNI) of Energy in 2005 to that in 2008?
Offer a very short reply. 1.34. What is the ratio of the Cost (as % of GNI) in Water in 2005 to that in 2008?
Make the answer very short. 1.32. What is the ratio of the Cost (as % of GNI) of Coal in 2006 to that in 2007?
Your answer should be compact. 1.29. What is the ratio of the Cost (as % of GNI) in Minerals in 2006 to that in 2007?
Your response must be concise. 0.76. What is the ratio of the Cost (as % of GNI) in Energy in 2006 to that in 2007?
Your answer should be compact. 1.32. What is the ratio of the Cost (as % of GNI) in Water in 2006 to that in 2007?
Your answer should be very brief. 1.3. What is the ratio of the Cost (as % of GNI) of Coal in 2006 to that in 2008?
Ensure brevity in your answer.  1.48. What is the ratio of the Cost (as % of GNI) in Energy in 2006 to that in 2008?
Give a very brief answer. 1.28. What is the ratio of the Cost (as % of GNI) in Water in 2006 to that in 2008?
Your response must be concise. 1.27. What is the ratio of the Cost (as % of GNI) in Coal in 2007 to that in 2008?
Your answer should be compact. 1.15. What is the ratio of the Cost (as % of GNI) in Minerals in 2007 to that in 2008?
Your answer should be very brief. 1.26. What is the ratio of the Cost (as % of GNI) in Energy in 2007 to that in 2008?
Ensure brevity in your answer.  0.97. What is the ratio of the Cost (as % of GNI) of Water in 2007 to that in 2008?
Ensure brevity in your answer.  0.98. What is the difference between the highest and the second highest Cost (as % of GNI) in Coal?
Your answer should be very brief. 0.21. What is the difference between the highest and the second highest Cost (as % of GNI) in Minerals?
Make the answer very short. 0.12. What is the difference between the highest and the second highest Cost (as % of GNI) of Energy?
Your response must be concise. 0.84. What is the difference between the highest and the second highest Cost (as % of GNI) of Water?
Your answer should be compact. 0.81. What is the difference between the highest and the lowest Cost (as % of GNI) in Coal?
Your answer should be very brief. 1.24. What is the difference between the highest and the lowest Cost (as % of GNI) of Minerals?
Your response must be concise. 0.43. What is the difference between the highest and the lowest Cost (as % of GNI) in Energy?
Your response must be concise. 8.01. What is the difference between the highest and the lowest Cost (as % of GNI) of Water?
Keep it short and to the point. 8.28. 